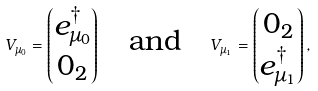Convert formula to latex. <formula><loc_0><loc_0><loc_500><loc_500>V _ { \mu _ { 0 } } = \begin{pmatrix} e ^ { \dagger } _ { \mu _ { 0 } } \\ 0 _ { 2 } \end{pmatrix} \quad \text {and} \quad V _ { \mu _ { 1 } } = \begin{pmatrix} 0 _ { 2 } \\ e ^ { \dagger } _ { \mu _ { 1 } } \end{pmatrix} ,</formula> 